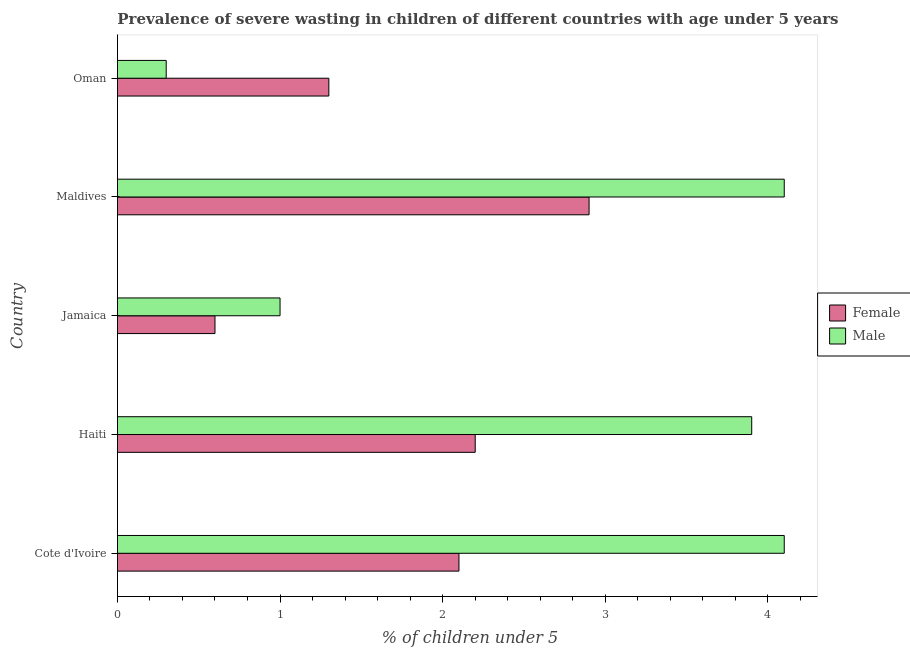How many bars are there on the 4th tick from the top?
Offer a terse response. 2. What is the label of the 4th group of bars from the top?
Your answer should be compact. Haiti. In how many cases, is the number of bars for a given country not equal to the number of legend labels?
Your response must be concise. 0. What is the percentage of undernourished female children in Haiti?
Make the answer very short. 2.2. Across all countries, what is the maximum percentage of undernourished female children?
Your response must be concise. 2.9. Across all countries, what is the minimum percentage of undernourished female children?
Make the answer very short. 0.6. In which country was the percentage of undernourished female children maximum?
Your answer should be compact. Maldives. In which country was the percentage of undernourished male children minimum?
Give a very brief answer. Oman. What is the total percentage of undernourished female children in the graph?
Keep it short and to the point. 9.1. What is the difference between the percentage of undernourished male children in Cote d'Ivoire and the percentage of undernourished female children in Maldives?
Your answer should be very brief. 1.2. What is the average percentage of undernourished male children per country?
Your answer should be compact. 2.68. What is the difference between the percentage of undernourished female children and percentage of undernourished male children in Oman?
Provide a short and direct response. 1. What is the ratio of the percentage of undernourished male children in Cote d'Ivoire to that in Haiti?
Offer a terse response. 1.05. Is the percentage of undernourished male children in Cote d'Ivoire less than that in Maldives?
Provide a succinct answer. No. What is the difference between the highest and the lowest percentage of undernourished male children?
Keep it short and to the point. 3.8. In how many countries, is the percentage of undernourished male children greater than the average percentage of undernourished male children taken over all countries?
Provide a short and direct response. 3. What does the 1st bar from the top in Maldives represents?
Offer a very short reply. Male. How many bars are there?
Provide a succinct answer. 10. Does the graph contain any zero values?
Provide a succinct answer. No. Does the graph contain grids?
Make the answer very short. No. How many legend labels are there?
Your answer should be compact. 2. How are the legend labels stacked?
Your response must be concise. Vertical. What is the title of the graph?
Your response must be concise. Prevalence of severe wasting in children of different countries with age under 5 years. Does "Commercial service exports" appear as one of the legend labels in the graph?
Make the answer very short. No. What is the label or title of the X-axis?
Make the answer very short.  % of children under 5. What is the  % of children under 5 in Female in Cote d'Ivoire?
Your answer should be very brief. 2.1. What is the  % of children under 5 in Male in Cote d'Ivoire?
Provide a succinct answer. 4.1. What is the  % of children under 5 of Female in Haiti?
Your response must be concise. 2.2. What is the  % of children under 5 in Male in Haiti?
Offer a very short reply. 3.9. What is the  % of children under 5 in Female in Jamaica?
Keep it short and to the point. 0.6. What is the  % of children under 5 in Male in Jamaica?
Keep it short and to the point. 1. What is the  % of children under 5 of Female in Maldives?
Your answer should be very brief. 2.9. What is the  % of children under 5 in Male in Maldives?
Your response must be concise. 4.1. What is the  % of children under 5 in Female in Oman?
Your answer should be very brief. 1.3. What is the  % of children under 5 in Male in Oman?
Your answer should be compact. 0.3. Across all countries, what is the maximum  % of children under 5 of Female?
Your answer should be very brief. 2.9. Across all countries, what is the maximum  % of children under 5 in Male?
Your answer should be very brief. 4.1. Across all countries, what is the minimum  % of children under 5 in Female?
Ensure brevity in your answer.  0.6. Across all countries, what is the minimum  % of children under 5 of Male?
Make the answer very short. 0.3. What is the total  % of children under 5 of Female in the graph?
Ensure brevity in your answer.  9.1. What is the total  % of children under 5 of Male in the graph?
Offer a very short reply. 13.4. What is the difference between the  % of children under 5 in Female in Cote d'Ivoire and that in Haiti?
Give a very brief answer. -0.1. What is the difference between the  % of children under 5 of Female in Cote d'Ivoire and that in Jamaica?
Provide a succinct answer. 1.5. What is the difference between the  % of children under 5 of Female in Cote d'Ivoire and that in Maldives?
Keep it short and to the point. -0.8. What is the difference between the  % of children under 5 in Male in Cote d'Ivoire and that in Maldives?
Offer a very short reply. 0. What is the difference between the  % of children under 5 in Female in Cote d'Ivoire and that in Oman?
Offer a very short reply. 0.8. What is the difference between the  % of children under 5 in Male in Cote d'Ivoire and that in Oman?
Your answer should be very brief. 3.8. What is the difference between the  % of children under 5 of Male in Haiti and that in Maldives?
Your answer should be compact. -0.2. What is the difference between the  % of children under 5 of Male in Haiti and that in Oman?
Your answer should be very brief. 3.6. What is the difference between the  % of children under 5 of Male in Jamaica and that in Maldives?
Give a very brief answer. -3.1. What is the difference between the  % of children under 5 of Female in Maldives and that in Oman?
Ensure brevity in your answer.  1.6. What is the difference between the  % of children under 5 of Female in Cote d'Ivoire and the  % of children under 5 of Male in Jamaica?
Your response must be concise. 1.1. What is the difference between the  % of children under 5 in Female in Cote d'Ivoire and the  % of children under 5 in Male in Maldives?
Provide a short and direct response. -2. What is the difference between the  % of children under 5 of Female in Haiti and the  % of children under 5 of Male in Oman?
Provide a succinct answer. 1.9. What is the difference between the  % of children under 5 in Female in Jamaica and the  % of children under 5 in Male in Maldives?
Give a very brief answer. -3.5. What is the difference between the  % of children under 5 of Female in Maldives and the  % of children under 5 of Male in Oman?
Make the answer very short. 2.6. What is the average  % of children under 5 of Female per country?
Offer a terse response. 1.82. What is the average  % of children under 5 of Male per country?
Ensure brevity in your answer.  2.68. What is the difference between the  % of children under 5 of Female and  % of children under 5 of Male in Haiti?
Ensure brevity in your answer.  -1.7. What is the difference between the  % of children under 5 in Female and  % of children under 5 in Male in Maldives?
Provide a succinct answer. -1.2. What is the ratio of the  % of children under 5 of Female in Cote d'Ivoire to that in Haiti?
Your answer should be very brief. 0.95. What is the ratio of the  % of children under 5 of Male in Cote d'Ivoire to that in Haiti?
Provide a succinct answer. 1.05. What is the ratio of the  % of children under 5 in Male in Cote d'Ivoire to that in Jamaica?
Your answer should be very brief. 4.1. What is the ratio of the  % of children under 5 of Female in Cote d'Ivoire to that in Maldives?
Your answer should be compact. 0.72. What is the ratio of the  % of children under 5 of Male in Cote d'Ivoire to that in Maldives?
Offer a very short reply. 1. What is the ratio of the  % of children under 5 in Female in Cote d'Ivoire to that in Oman?
Your answer should be very brief. 1.62. What is the ratio of the  % of children under 5 in Male in Cote d'Ivoire to that in Oman?
Give a very brief answer. 13.67. What is the ratio of the  % of children under 5 in Female in Haiti to that in Jamaica?
Your response must be concise. 3.67. What is the ratio of the  % of children under 5 of Male in Haiti to that in Jamaica?
Give a very brief answer. 3.9. What is the ratio of the  % of children under 5 in Female in Haiti to that in Maldives?
Give a very brief answer. 0.76. What is the ratio of the  % of children under 5 in Male in Haiti to that in Maldives?
Offer a terse response. 0.95. What is the ratio of the  % of children under 5 of Female in Haiti to that in Oman?
Offer a very short reply. 1.69. What is the ratio of the  % of children under 5 of Female in Jamaica to that in Maldives?
Make the answer very short. 0.21. What is the ratio of the  % of children under 5 of Male in Jamaica to that in Maldives?
Give a very brief answer. 0.24. What is the ratio of the  % of children under 5 in Female in Jamaica to that in Oman?
Make the answer very short. 0.46. What is the ratio of the  % of children under 5 in Female in Maldives to that in Oman?
Give a very brief answer. 2.23. What is the ratio of the  % of children under 5 of Male in Maldives to that in Oman?
Offer a very short reply. 13.67. What is the difference between the highest and the second highest  % of children under 5 of Female?
Offer a terse response. 0.7. What is the difference between the highest and the lowest  % of children under 5 of Male?
Your answer should be very brief. 3.8. 